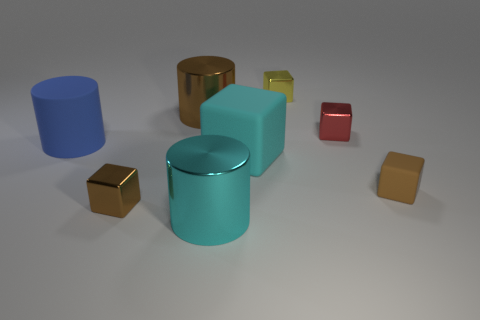Subtract all cyan cubes. How many cubes are left? 4 Subtract all yellow cubes. How many cubes are left? 4 Subtract all gray blocks. Subtract all red balls. How many blocks are left? 5 Add 1 brown cylinders. How many objects exist? 9 Subtract all cubes. How many objects are left? 3 Add 6 large gray metallic cylinders. How many large gray metallic cylinders exist? 6 Subtract 0 yellow spheres. How many objects are left? 8 Subtract all big blue matte cubes. Subtract all cyan matte blocks. How many objects are left? 7 Add 4 cyan objects. How many cyan objects are left? 6 